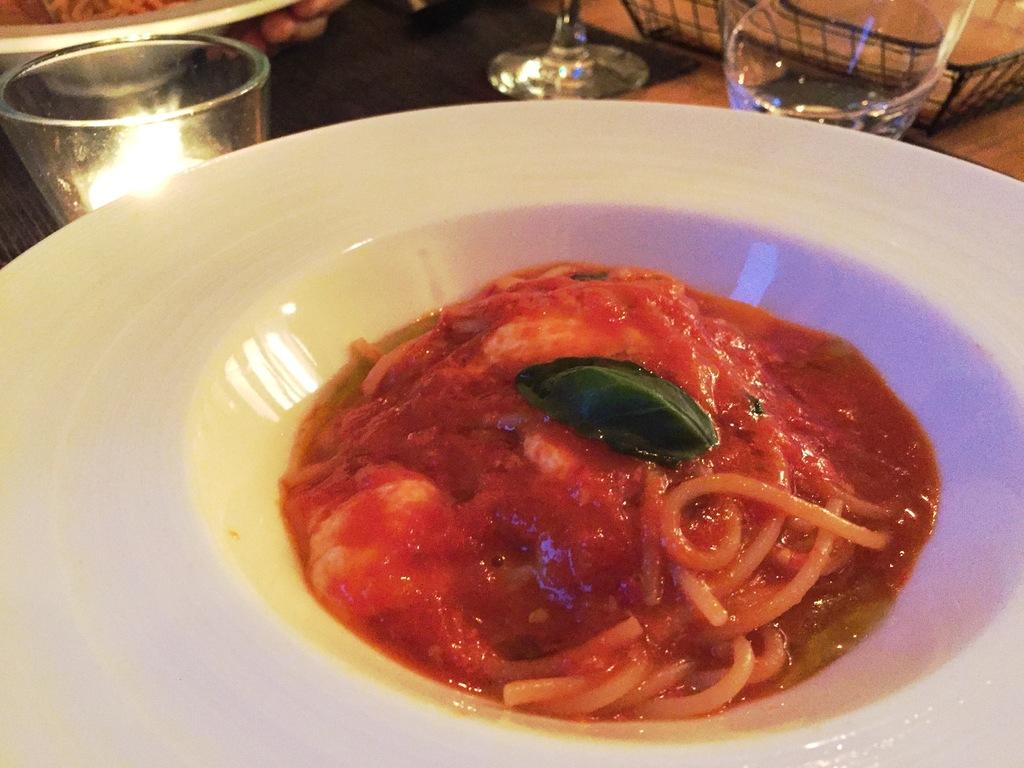What is on the plate that is visible in the image? There is food on a plate in the image. What else can be seen in the image besides the plate with food? There are glasses and plates visible in the image. What is on the table in the image? There is a basket on the table in the image. Who is holding a plate in the image? There is a person holding a plate in the image. What type of cracker is being sold at the market in the image? There is no market or cracker present in the image. How much steam is rising from the food on the plate in the image? There is no steam visible in the image; the food appears to be at room temperature. 